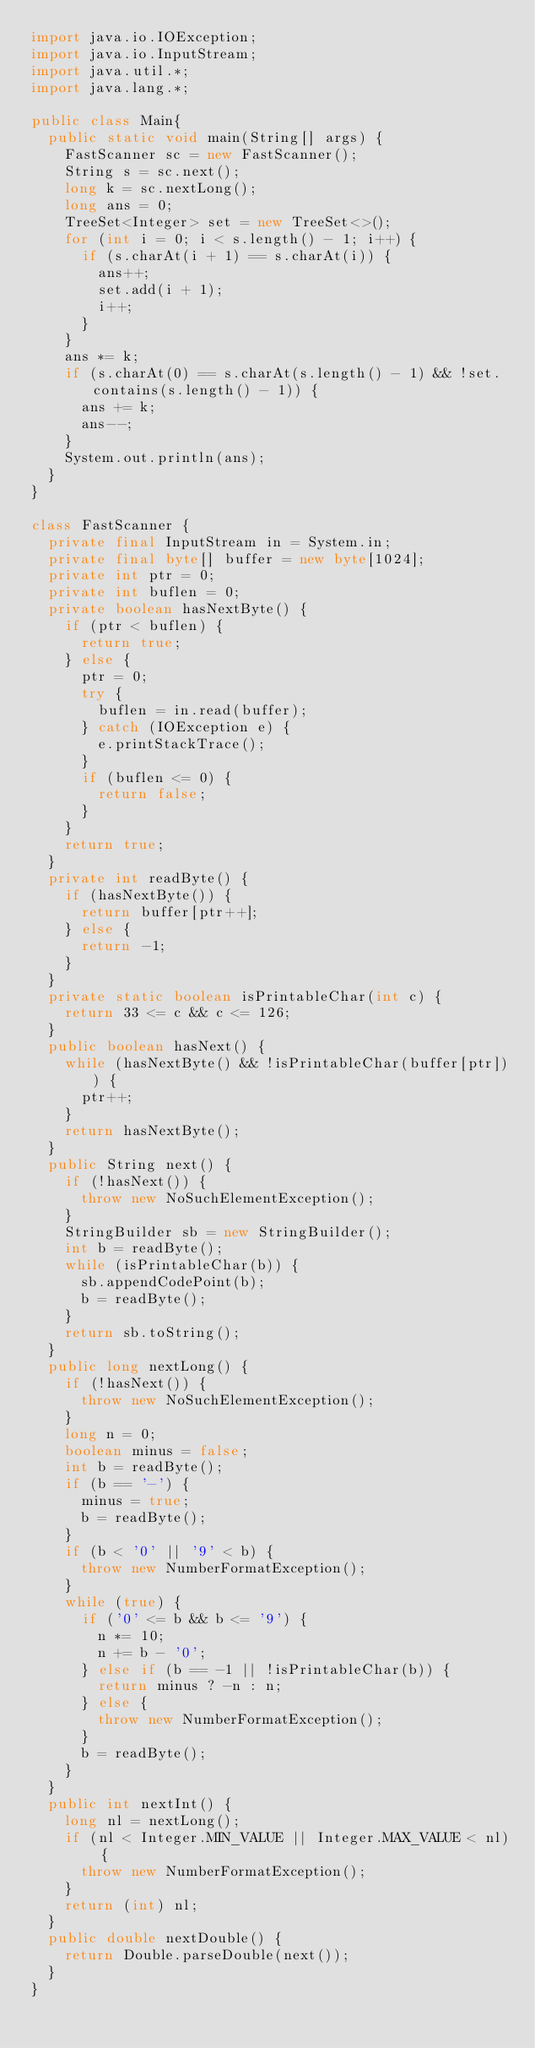Convert code to text. <code><loc_0><loc_0><loc_500><loc_500><_Java_>import java.io.IOException;
import java.io.InputStream;
import java.util.*;
import java.lang.*;

public class Main{
	public static void main(String[] args) {
		FastScanner sc = new FastScanner();
		String s = sc.next();
		long k = sc.nextLong();
		long ans = 0;
		TreeSet<Integer> set = new TreeSet<>();
		for (int i = 0; i < s.length() - 1; i++) {
			if (s.charAt(i + 1) == s.charAt(i)) {
				ans++;
				set.add(i + 1);
				i++;
			}
		}
		ans *= k;
		if (s.charAt(0) == s.charAt(s.length() - 1) && !set.contains(s.length() - 1)) {
			ans += k;
			ans--;
		}
		System.out.println(ans);
	}
}

class FastScanner {
	private final InputStream in = System.in;
	private final byte[] buffer = new byte[1024];
	private int ptr = 0;
	private int buflen = 0;
	private boolean hasNextByte() {
		if (ptr < buflen) {
			return true;
		} else {
			ptr = 0;
			try {
				buflen = in.read(buffer);
			} catch (IOException e) {
				e.printStackTrace();
			}
			if (buflen <= 0) {
				return false;
			}
		}
		return true;
	}
	private int readByte() {
		if (hasNextByte()) {
			return buffer[ptr++];
		} else {
			return -1;
		}
	}
	private static boolean isPrintableChar(int c) {
		return 33 <= c && c <= 126;
	}
	public boolean hasNext() {
		while (hasNextByte() && !isPrintableChar(buffer[ptr])) {
			ptr++;
		}
		return hasNextByte();
	}
	public String next() {
		if (!hasNext()) {
			throw new NoSuchElementException();
		}
		StringBuilder sb = new StringBuilder();
		int b = readByte();
		while (isPrintableChar(b)) {
			sb.appendCodePoint(b);
			b = readByte();
		}
		return sb.toString();
	}
	public long nextLong() {
		if (!hasNext()) {
			throw new NoSuchElementException();
		}
		long n = 0;
		boolean minus = false;
		int b = readByte();
		if (b == '-') {
			minus = true;
			b = readByte();
		}
		if (b < '0' || '9' < b) {
			throw new NumberFormatException();
		}
		while (true) {
			if ('0' <= b && b <= '9') {
				n *= 10;
				n += b - '0';
			} else if (b == -1 || !isPrintableChar(b)) {
				return minus ? -n : n;
			} else {
				throw new NumberFormatException();
			}
			b = readByte();
		}
	}
	public int nextInt() {
		long nl = nextLong();
		if (nl < Integer.MIN_VALUE || Integer.MAX_VALUE < nl) {
			throw new NumberFormatException();
		}
		return (int) nl;
	}
	public double nextDouble() {
		return Double.parseDouble(next());
	}
}
</code> 